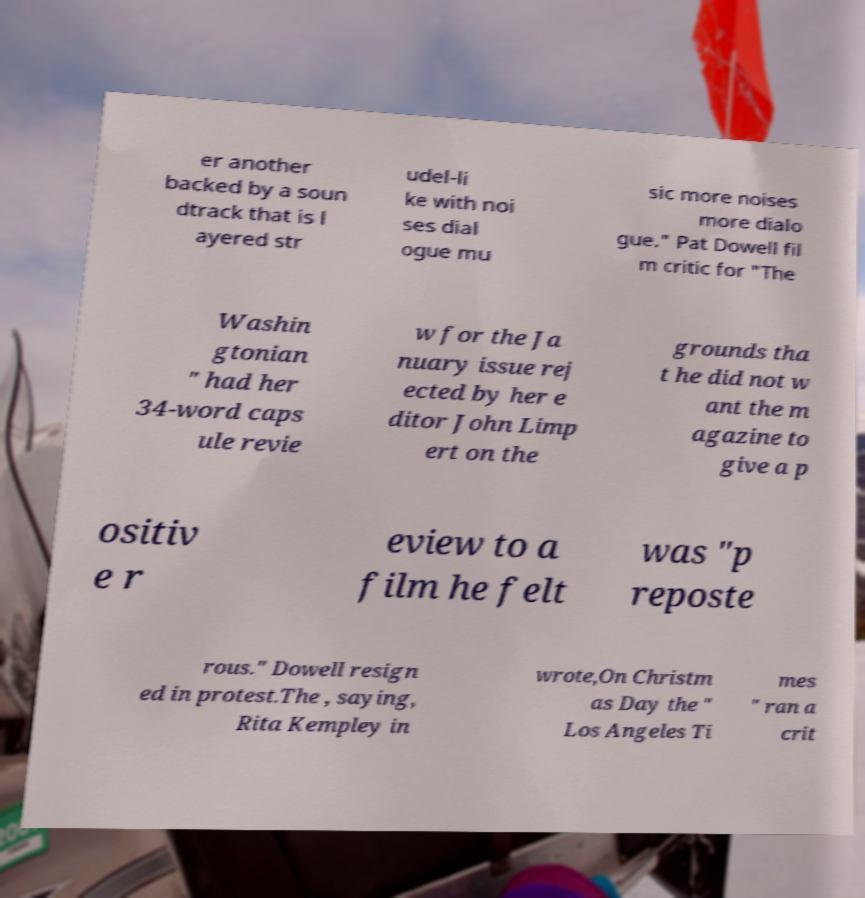There's text embedded in this image that I need extracted. Can you transcribe it verbatim? er another backed by a soun dtrack that is l ayered str udel-li ke with noi ses dial ogue mu sic more noises more dialo gue." Pat Dowell fil m critic for "The Washin gtonian " had her 34-word caps ule revie w for the Ja nuary issue rej ected by her e ditor John Limp ert on the grounds tha t he did not w ant the m agazine to give a p ositiv e r eview to a film he felt was "p reposte rous." Dowell resign ed in protest.The , saying, Rita Kempley in wrote,On Christm as Day the " Los Angeles Ti mes " ran a crit 